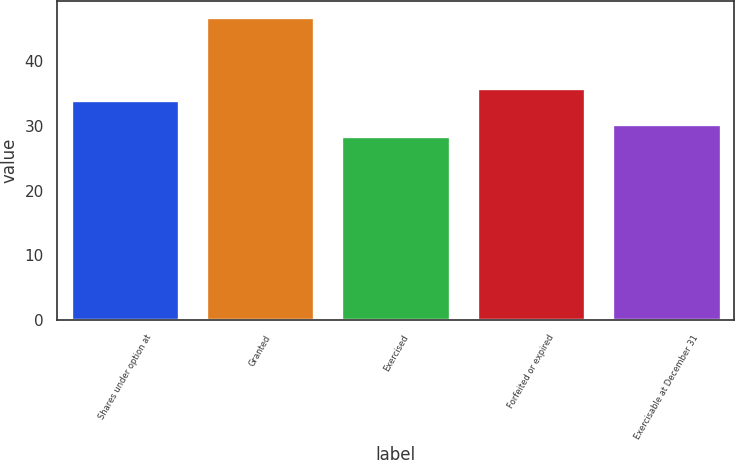<chart> <loc_0><loc_0><loc_500><loc_500><bar_chart><fcel>Shares under option at<fcel>Granted<fcel>Exercised<fcel>Forfeited or expired<fcel>Exercisable at December 31<nl><fcel>33.97<fcel>46.92<fcel>28.42<fcel>35.82<fcel>30.27<nl></chart> 